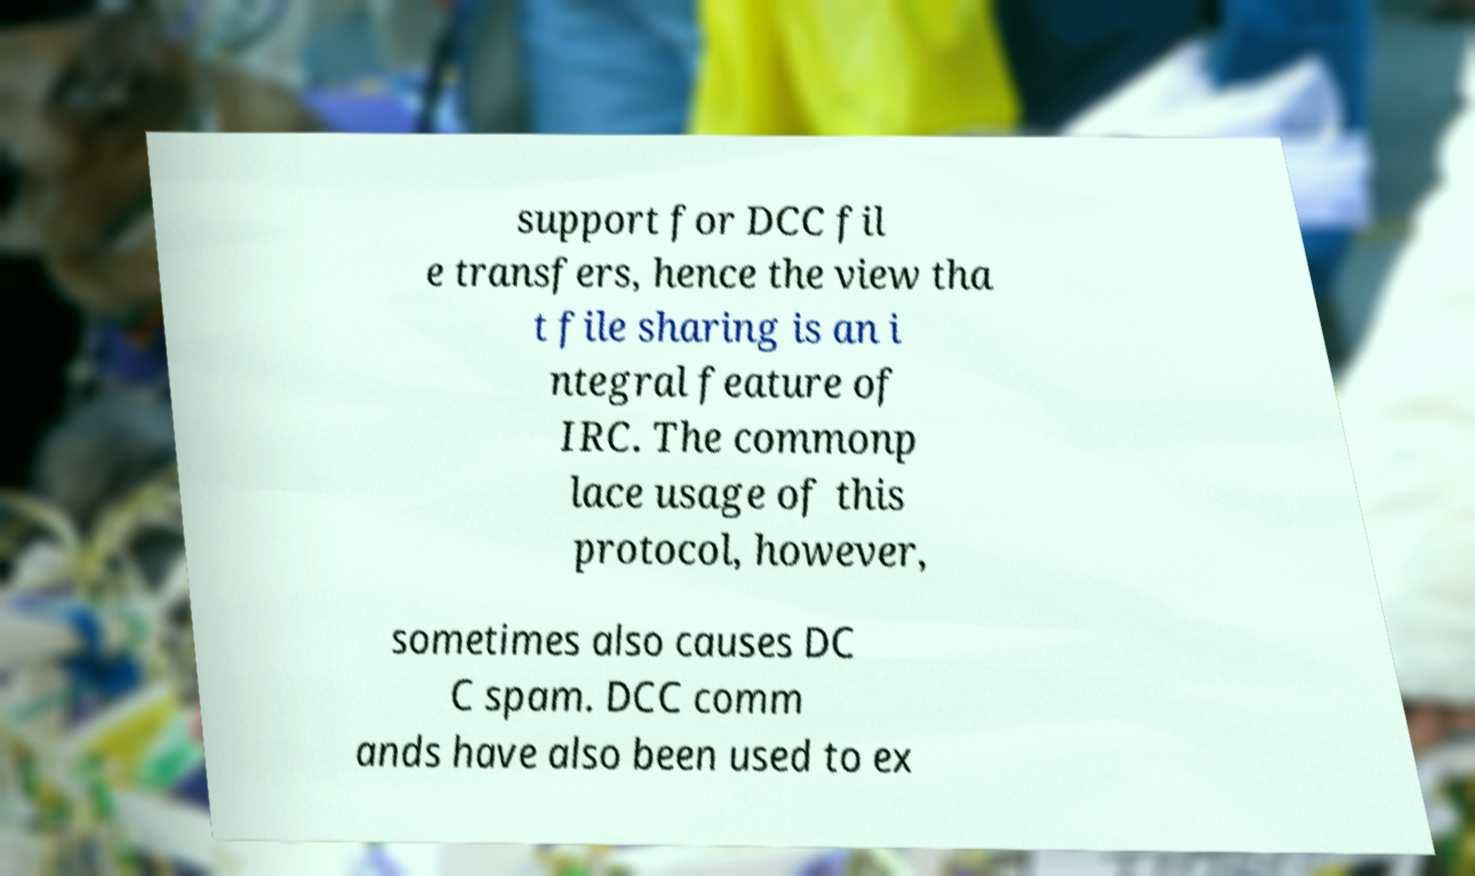Could you extract and type out the text from this image? support for DCC fil e transfers, hence the view tha t file sharing is an i ntegral feature of IRC. The commonp lace usage of this protocol, however, sometimes also causes DC C spam. DCC comm ands have also been used to ex 